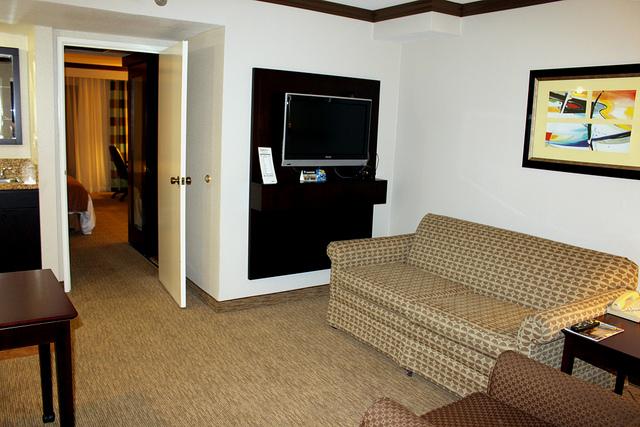Is the person who lives here neat?
Quick response, please. Yes. What type of room is in the foreground?
Quick response, please. Living room. How long is couch?
Give a very brief answer. 5 feet. Is the television on?
Keep it brief. No. 